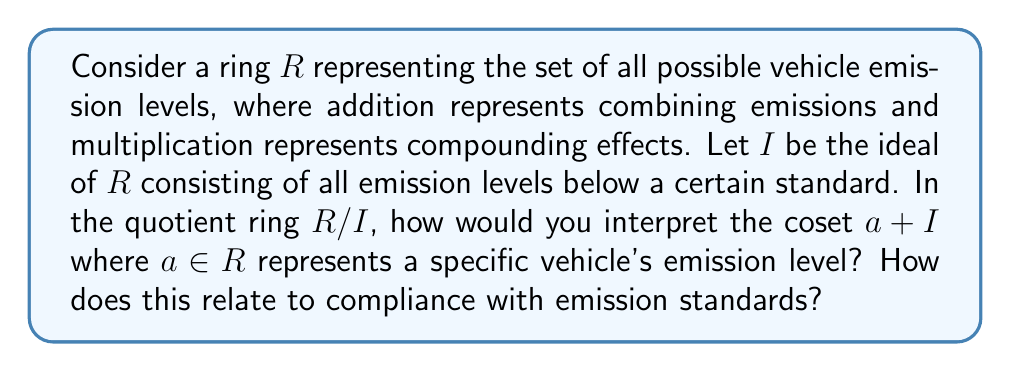Could you help me with this problem? To understand this question, let's break it down step-by-step:

1) Ring $R$: This represents all possible emission levels. Elements in $R$ could be thought of as numerical values representing emission quantities.

2) Ideal $I$: This represents all emission levels below the standard. Mathematically, $I = \{x \in R : x < \text{standard}\}$.

3) Quotient ring $R/I$: This ring represents emission levels modulo the standard. It essentially groups all emission levels that differ by an amount below the standard.

4) Coset $a + I$: In the quotient ring, this represents all emission levels that differ from $a$ by an element of $I$.

Interpretation:
- If $a \in I$, then $a + I = I$, the zero element in $R/I$. This means the vehicle's emissions are below the standard.
- If $a \notin I$, then $a + I \neq I$. This means the vehicle's emissions exceed the standard.

The coset $a + I$ can be interpreted as an equivalence class of emission levels. All elements in this class are considered equivalent in terms of compliance with the emission standard.

Relation to compliance:
1) Compliance is binary in $R/I$: a vehicle either complies (represented by the zero element $I$) or doesn't (represented by any non-zero element).
2) The quotient ring structure simplifies the emission landscape by grouping together all emission levels that are equivalent in terms of compliance.
3) This modeling allows for easy categorization of vehicles into compliant and non-compliant groups, which is crucial for vehicle rights advocates arguing for or against certain emission standards.
Answer: The coset $a + I$ in $R/I$ represents an equivalence class of emission levels that are considered the same in terms of compliance with the emission standard. If $a + I = I$, the vehicle complies with the standard; if $a + I \neq I$, it doesn't. This structure simplifies emission compliance to a binary state, facilitating clear categorization of vehicles for regulatory purposes. 